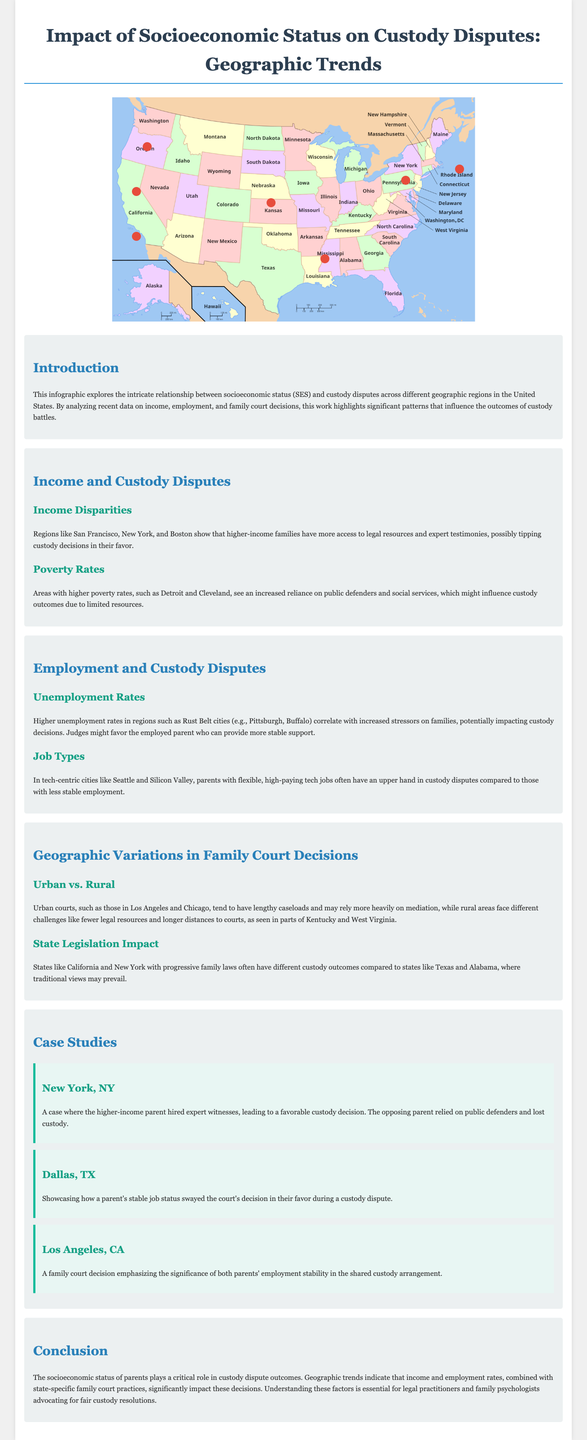what is the title of the infographic? The title of the infographic is found at the top of the document.
Answer: Impact of Socioeconomic Status on Custody Disputes: Geographic Trends which city is associated with higher income and more legal resources? San Francisco is specifically mentioned in the infographic for its higher income and resources in custody disputes.
Answer: San Francisco what is the average unemployment rate in Pittsburgh? The infographic discusses unemployment rates correlating with custody disputes but does not provide a specific number for Pittsburgh's unemployment rate.
Answer: Not available which regions have higher poverty rates and increased reliance on public defenders? The infographic states that Detroit and Cleveland are regions noted for higher poverty rates and public defender reliance.
Answer: Detroit and Cleveland what type of jobs give parents an advantage in custody disputes in Seattle? The infographic notes that high-paying tech jobs provide an advantage in custody disputes in Seattle.
Answer: Tech jobs how do urban courts compare with rural courts in terms of mediation? The infographic indicates that urban courts, like those in Los Angeles, rely more heavily on mediation compared to rural courts.
Answer: Rely more heavily on mediation which state has more progressive family laws impacting custody outcomes? The infographic mentions California and New York as states with progressive family laws affecting custody outcomes.
Answer: California and New York what does the case study from Dallas highlight? The Dallas case study emphasizes how job stability influenced court decisions in a custody dispute.
Answer: Job stability 